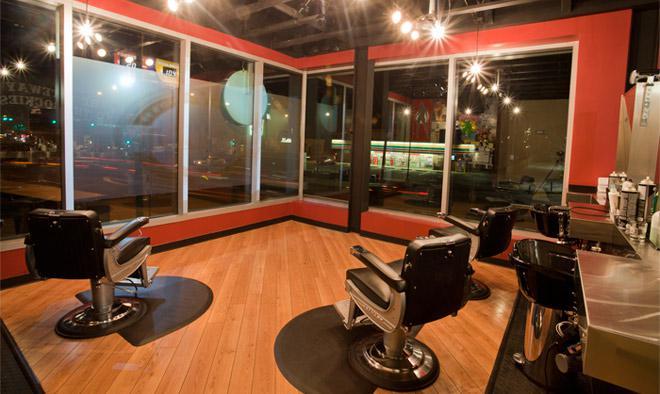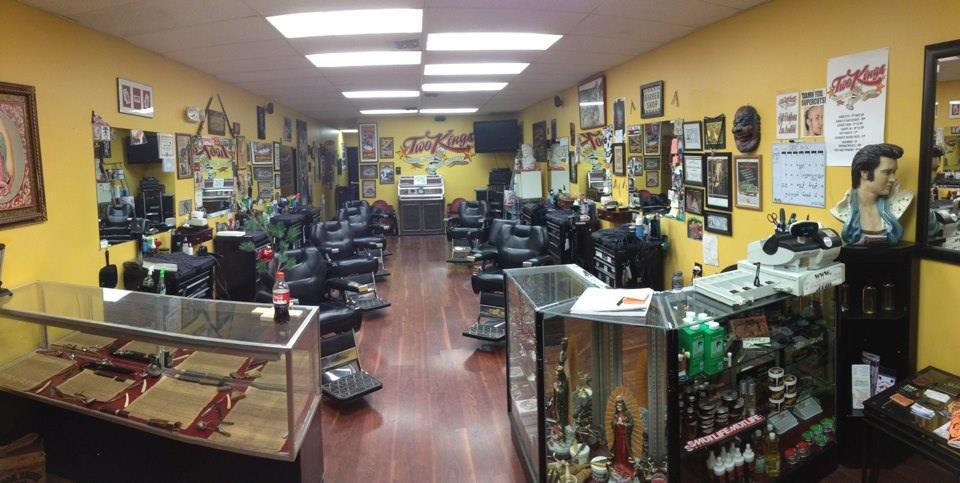The first image is the image on the left, the second image is the image on the right. Given the left and right images, does the statement "there are people in the image on the left" hold true? Answer yes or no. No. The first image is the image on the left, the second image is the image on the right. Analyze the images presented: Is the assertion "There are no people visible in the images." valid? Answer yes or no. Yes. 